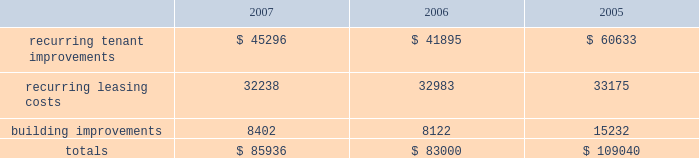In february 2008 , we issued $ 300.0 million of 8.375% ( 8.375 % ) series o cumulative redeemable preferred shares .
The indentures ( and related supplemental indentures ) governing our outstanding series of notes also require us to comply with financial ratios and other covenants regarding our operations .
We were in compliance with all such covenants as of december 31 , 2007 .
Sale of real estate assets we utilize sales of real estate assets as an additional source of liquidity .
We pursue opportunities to sell real estate assets at favorable prices to capture value created by us as well as to improve the overall quality of our portfolio by recycling sale proceeds into new properties with greater value creation opportunities .
Uses of liquidity our principal uses of liquidity include the following : 2022 property investments ; 2022 recurring leasing/capital costs ; 2022 dividends and distributions to shareholders and unitholders ; 2022 long-term debt maturities ; and 2022 other contractual obligations property investments we evaluate development and acquisition opportunities based upon market outlook , supply and long-term growth potential .
Recurring expenditures one of our principal uses of our liquidity is to fund the recurring leasing/capital expenditures of our real estate investments .
The following is a summary of our recurring capital expenditures for the years ended december 31 , 2007 , 2006 and 2005 , respectively ( in thousands ) : .
Dividends and distributions in order to qualify as a reit for federal income tax purposes , we must currently distribute at least 90% ( 90 % ) of our taxable income to shareholders .
We paid dividends per share of $ 1.91 , $ 1.89 and $ 1.87 for the years ended december 31 , 2007 , 2006 and 2005 , respectively .
We also paid a one-time special dividend of $ 1.05 per share in 2005 as a result of the significant gain realized from an industrial portfolio sale .
We expect to continue to distribute taxable earnings to meet the requirements to maintain our reit status .
However , distributions are declared at the discretion of our board of directors and are subject to actual cash available for distribution , our financial condition , capital requirements and such other factors as our board of directors deems relevant .
Debt maturities debt outstanding at december 31 , 2007 totaled $ 4.3 billion with a weighted average interest rate of 5.74% ( 5.74 % ) maturing at various dates through 2028 .
We had $ 3.2 billion of unsecured notes , $ 546.1 million outstanding on our unsecured lines of credit and $ 524.4 million of secured debt outstanding at december 31 , 2007 .
Scheduled principal amortization and maturities of such debt totaled $ 249.8 million for the year ended december 31 , 2007 and $ 146.4 million of secured debt was transferred to unconsolidated subsidiaries in connection with the contribution of properties in 2007. .
What was the percent of the growth in the recurring tenant improvements from 2006 to 2007? 
Computations: ((45296 - 41895) / 41895)
Answer: 0.08118. 